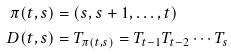Convert formula to latex. <formula><loc_0><loc_0><loc_500><loc_500>\pi ( t , s ) & = ( s , s + 1 , \dots , t ) \\ D ( t , s ) & = T _ { \pi ( t , s ) } = T _ { t - 1 } T _ { t - 2 } \cdots T _ { s }</formula> 